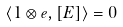Convert formula to latex. <formula><loc_0><loc_0><loc_500><loc_500>\langle 1 \otimes e , [ E ] \rangle = 0</formula> 